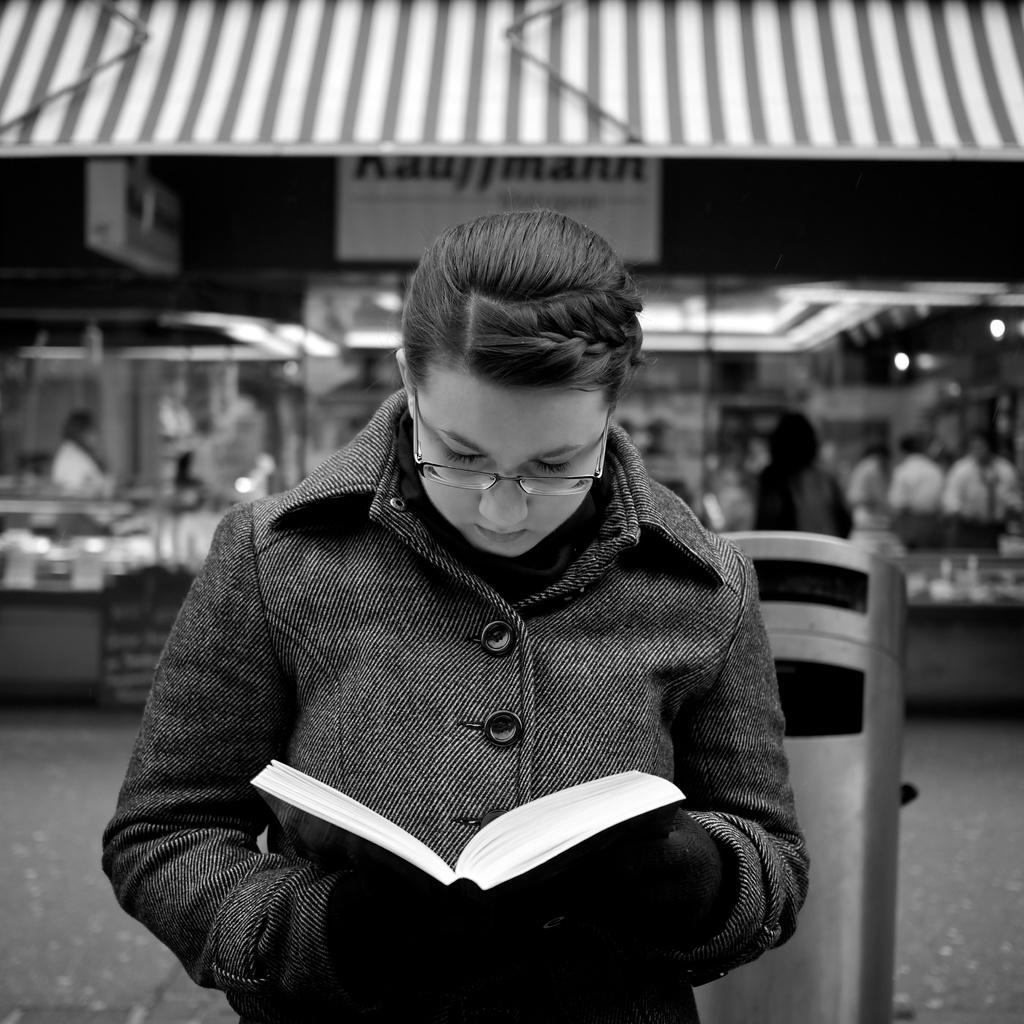Who is the main subject in the image? There is a lady in the image. What is the lady doing in the image? The lady is standing in the image. What is the lady holding in her hand? The lady is holding a book in her hand. What can be seen behind the lady? There is an object behind the lady, as well as a stall. What is happening near the stall in the image? There are people standing in front of the stall in the image. What type of cabbage is being served in the lunchroom in the image? There is no lunchroom or cabbage present in the image. What company does the lady represent in the image? There is no indication of a company or representation in the image. 